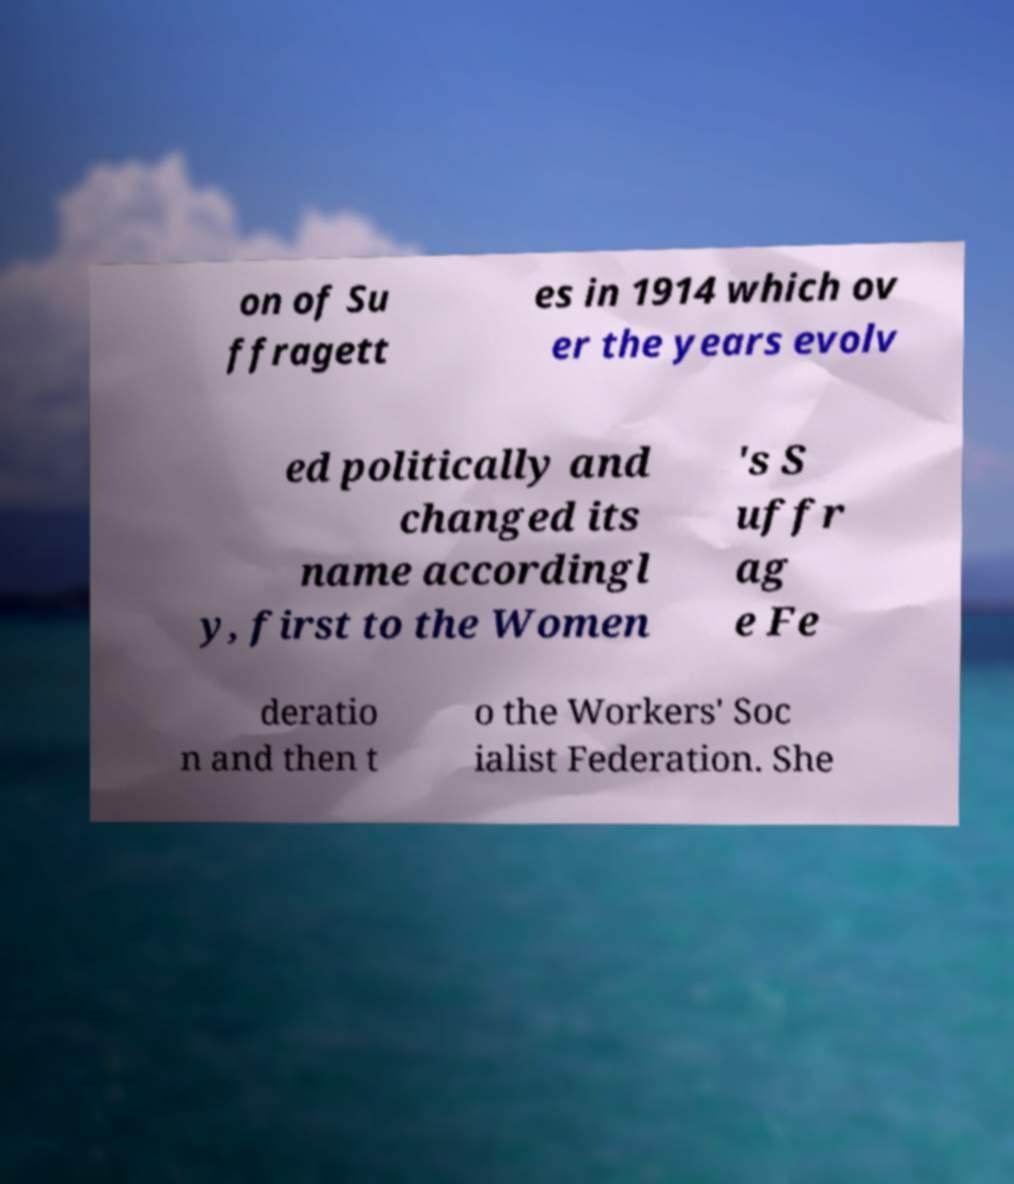What messages or text are displayed in this image? I need them in a readable, typed format. on of Su ffragett es in 1914 which ov er the years evolv ed politically and changed its name accordingl y, first to the Women 's S uffr ag e Fe deratio n and then t o the Workers' Soc ialist Federation. She 